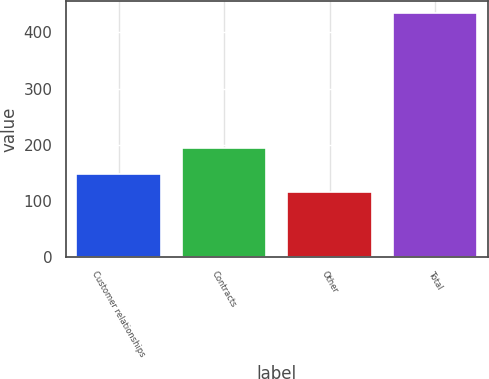Convert chart to OTSL. <chart><loc_0><loc_0><loc_500><loc_500><bar_chart><fcel>Customer relationships<fcel>Contracts<fcel>Other<fcel>Total<nl><fcel>147.8<fcel>194<fcel>116<fcel>434<nl></chart> 